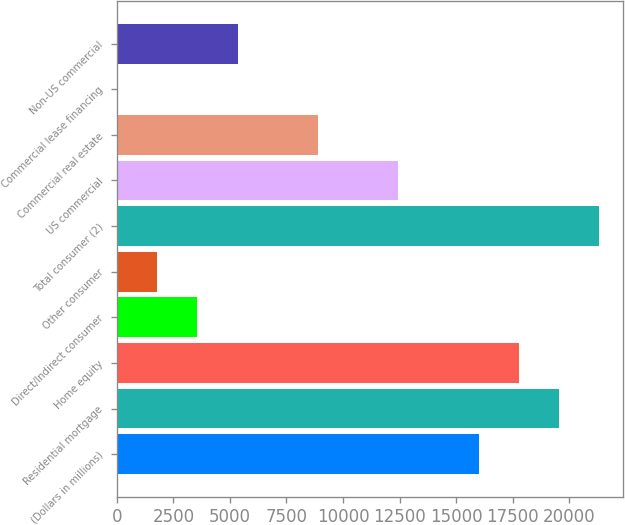Convert chart. <chart><loc_0><loc_0><loc_500><loc_500><bar_chart><fcel>(Dollars in millions)<fcel>Residential mortgage<fcel>Home equity<fcel>Direct/Indirect consumer<fcel>Other consumer<fcel>Total consumer (2)<fcel>US commercial<fcel>Commercial real estate<fcel>Commercial lease financing<fcel>Non-US commercial<nl><fcel>15996.4<fcel>19547.6<fcel>17772<fcel>3567.2<fcel>1791.6<fcel>21323.2<fcel>12445.2<fcel>8894<fcel>16<fcel>5342.8<nl></chart> 